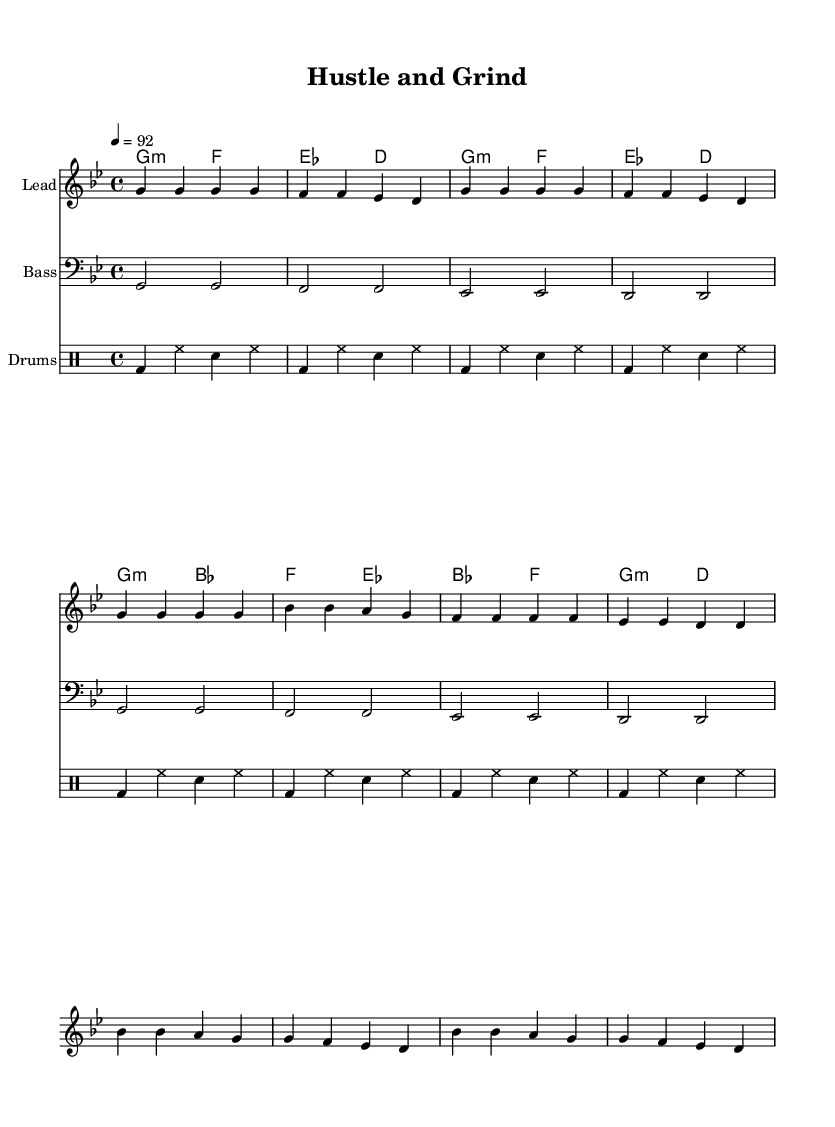What is the key signature of this music? The key signature is G minor, which has two flats (B flat and E flat). This can be identified at the beginning of the sheet music where the key signature is indicated.
Answer: G minor What is the time signature of this music? The time signature is 4/4, which means there are four beats in each measure and a quarter note gets one beat. This is visible at the start of the piece right after the key signature.
Answer: 4/4 What is the tempo marking of this music? The tempo is set at 92 beats per minute, indicated by the term "4 = 92" at the beginning, where it refers to the number of beats per minute for a quarter note.
Answer: 92 How many measures are in the chorus section? The chorus section contains four measures, which can be counted from the notated music and lyrics in the chorus section of the sheet. Each line corresponds to a measure.
Answer: 4 What is the main lyrical theme of the verse? The lyrical theme of the verse revolves around hustling and building an empire, as summarized in the lines provided in the verse section of the lyrics. This emphasizes the entrepreneurial spirit and determination.
Answer: Hustling Which instrument plays the bass line? The bass line is played by a bass staff, as indicated in the music notation. The specific clef used for the bass line is the bass clef which supports the low pitch sounds characteristic of bass instruments.
Answer: Bass What unique rhythmic element is present in the drum patterns? The unique rhythmic element present in the drum patterns is the bass drum paired with the hi-hat, which creates a consistent and driving beat. This is evident from the repeated notation in the drum patterns section.
Answer: Bass drum and hi-hat 